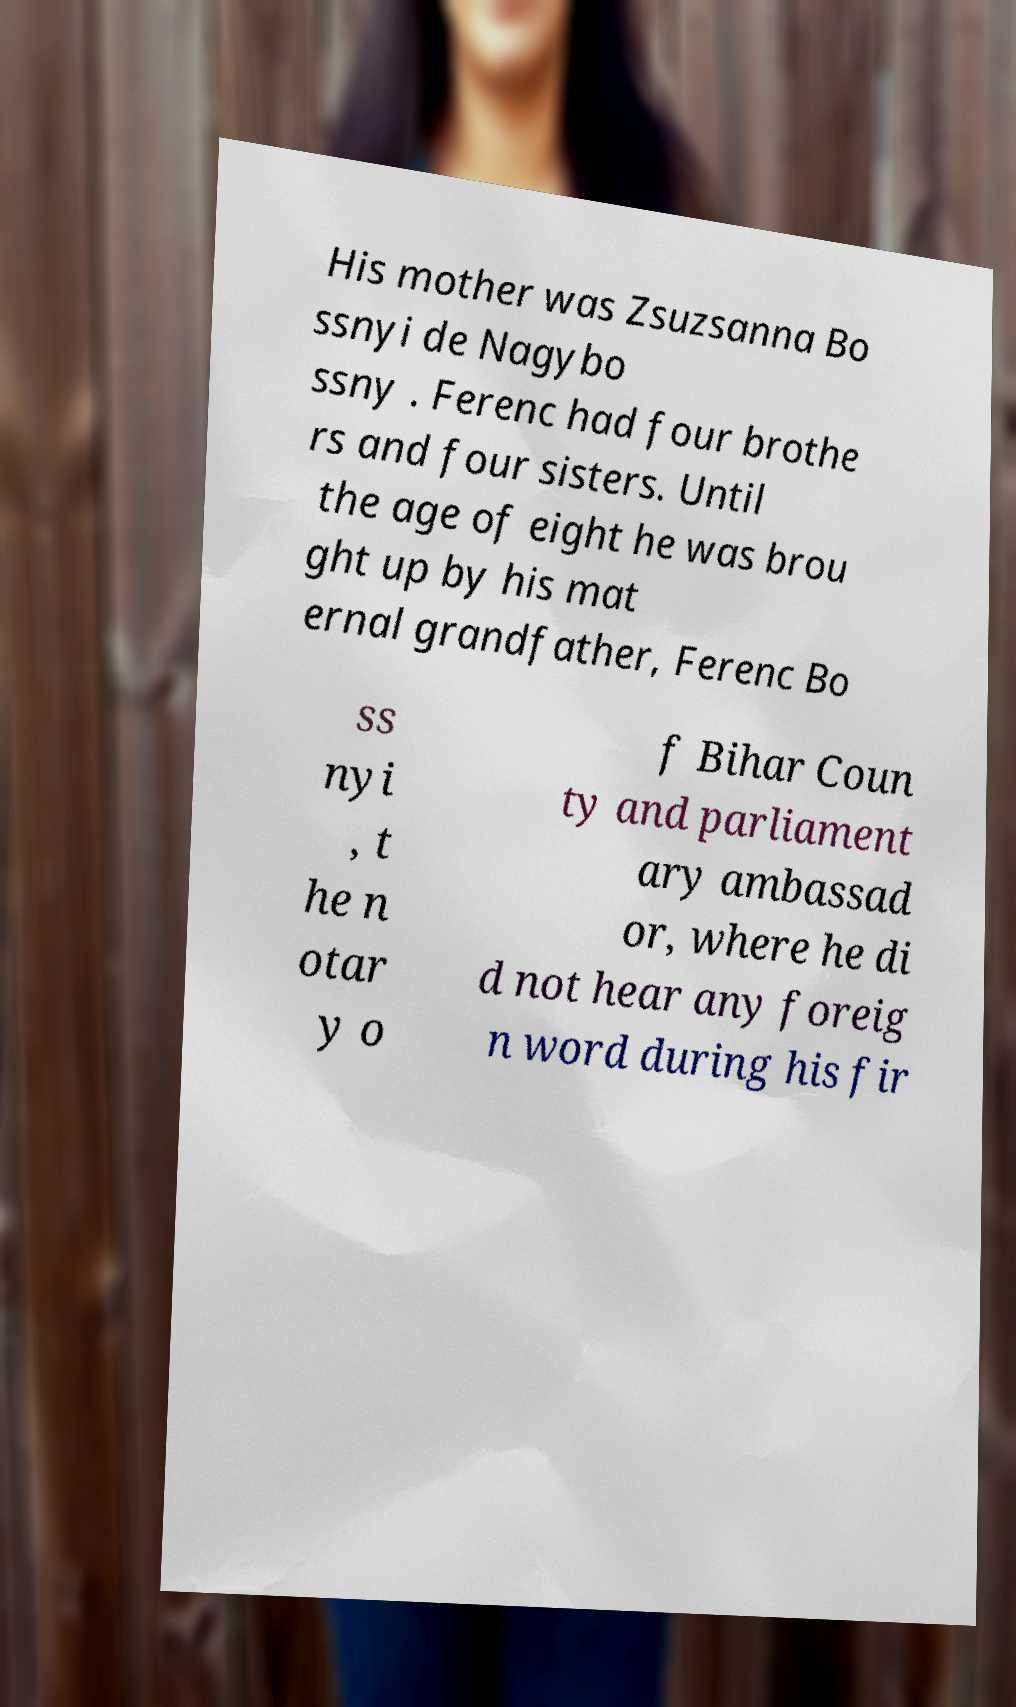Please read and relay the text visible in this image. What does it say? His mother was Zsuzsanna Bo ssnyi de Nagybo ssny . Ferenc had four brothe rs and four sisters. Until the age of eight he was brou ght up by his mat ernal grandfather, Ferenc Bo ss nyi , t he n otar y o f Bihar Coun ty and parliament ary ambassad or, where he di d not hear any foreig n word during his fir 